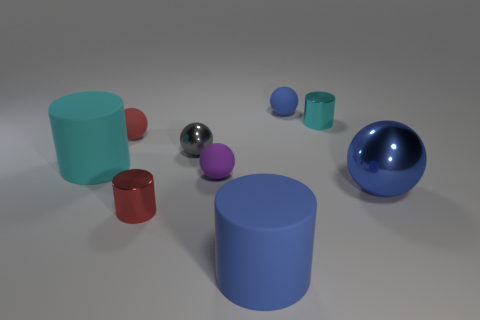Is there a small cylinder that is behind the metal sphere that is to the right of the cyan metallic thing?
Your answer should be very brief. Yes. There is a blue matte object that is to the left of the blue thing that is behind the cyan metal object; are there any big cylinders in front of it?
Make the answer very short. No. Is the shape of the large rubber thing right of the cyan rubber object the same as the big blue object to the right of the blue rubber cylinder?
Keep it short and to the point. No. The large thing that is made of the same material as the gray sphere is what color?
Your response must be concise. Blue. Is the number of tiny purple objects that are right of the small purple rubber object less than the number of tiny yellow rubber balls?
Provide a succinct answer. No. What size is the cyan thing that is to the left of the matte cylinder that is in front of the small metallic cylinder that is to the left of the cyan metal cylinder?
Provide a succinct answer. Large. Is the cylinder that is in front of the red metal cylinder made of the same material as the tiny blue thing?
Provide a short and direct response. Yes. There is a big cylinder that is the same color as the large metallic sphere; what is its material?
Your answer should be very brief. Rubber. Are there any other things that are the same shape as the cyan matte object?
Your answer should be very brief. Yes. How many objects are either small cyan cylinders or blue metal cubes?
Keep it short and to the point. 1. 